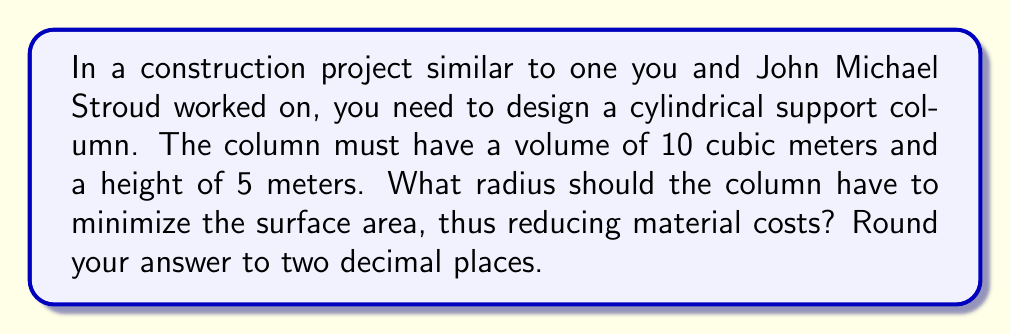Can you answer this question? Let's approach this step-by-step:

1) First, we need to express the volume and surface area of the cylinder in terms of its radius $r$ and height $h$:

   Volume: $V = \pi r^2 h$
   Surface Area: $S = 2\pi r^2 + 2\pi r h$

2) We're given that the volume is 10 m³ and the height is 5 m. Let's substitute these into the volume equation:

   $10 = \pi r^2 (5)$

3) Solve this for $r^2$:

   $r^2 = \frac{10}{5\pi} = \frac{2}{\pi}$

4) Now, we can express the surface area solely in terms of $r$:

   $S = 2\pi r^2 + 2\pi r (5)$
   $S = 2\pi (\frac{2}{\pi}) + 10\pi r$
   $S = 4 + 10\pi r$

5) To minimize $S$, we need to find where its derivative with respect to $r$ is zero:

   $\frac{dS}{dr} = 10\pi$

6) Setting this equal to zero:

   $10\pi = 0$

   This is never true, which means there's no minimum or maximum within the domain.

7) However, we know that $r^2 = \frac{2}{\pi}$, so:

   $r = \sqrt{\frac{2}{\pi}} \approx 0.7979$ meters
Answer: 0.80 m 